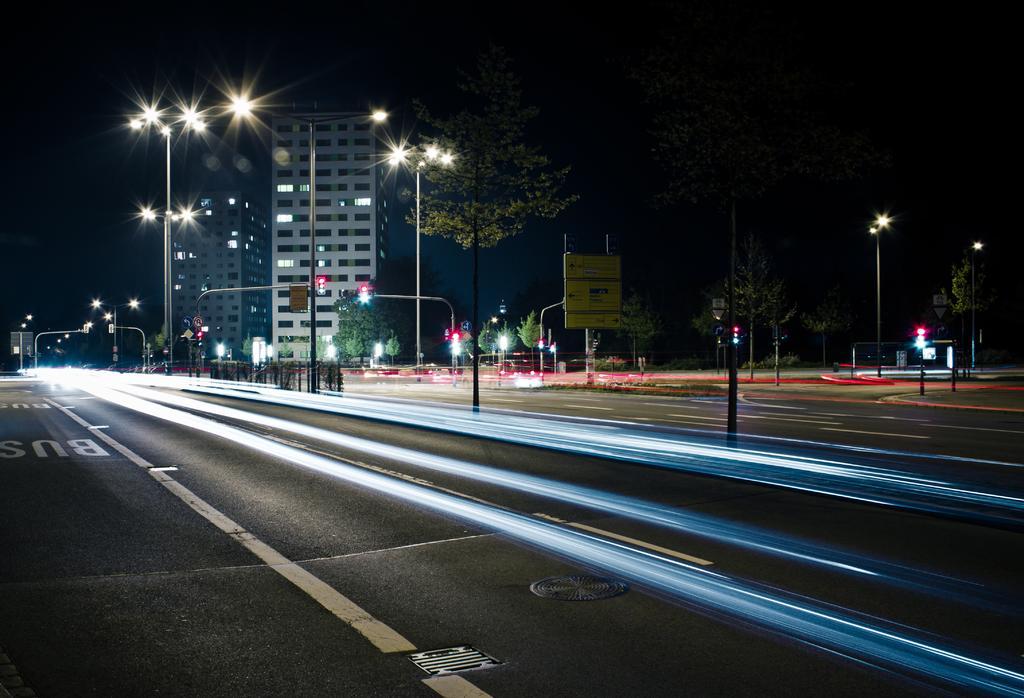Please provide a concise description of this image. This is a road. I can see the traffic signals attached to the poles. These are the street lights. I can see the buildings with the windows and lights. This looks like a board, which is attached to a pole. These are the trees. 